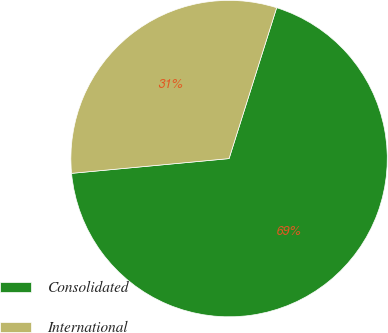Convert chart to OTSL. <chart><loc_0><loc_0><loc_500><loc_500><pie_chart><fcel>Consolidated<fcel>International<nl><fcel>68.65%<fcel>31.35%<nl></chart> 